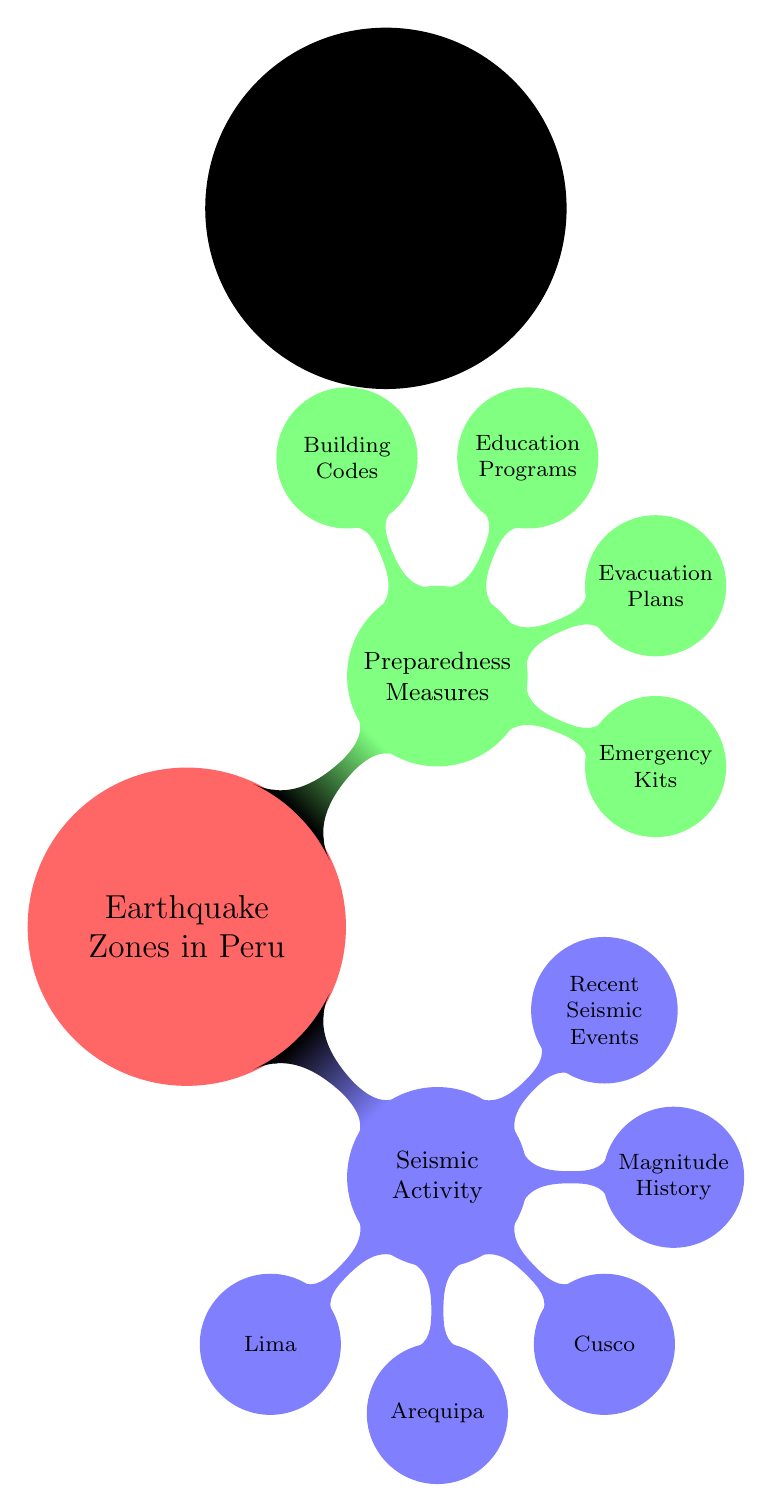What are the main categories shown in the diagram? The diagram has two main categories: "Seismic Activity" and "Preparedness Measures". These are the primary branches stemming from the central concept "Earthquake Zones in Peru".
Answer: Seismic Activity, Preparedness Measures How many locations are listed under "Seismic Activity"? Under "Seismic Activity," there are three locations mentioned: Lima, Arequipa, and Cusco. Thus, the total count is three.
Answer: 3 What specific precautionary measure is included under "Preparedness Measures"? The diagram lists several precautionary measures, including "Emergency Kits," which is one of the sub-nodes under "Preparedness Measures". This denotes an important aspect of earthquake preparedness.
Answer: Emergency Kits What is the relationship between "Magnitude History" and "Seismic Activity"? "Magnitude History" is a child node that falls under the parent node "Seismic Activity". This indicates that it is a subtopic that describes the historical earthquake magnitudes related to seismic activity.
Answer: Subtopic Which node has the greatest focus on education? The node "Education Programs" specifically emphasizes educational measures in relation to preparedness. It is clearly identified as a subtopic under "Preparedness Measures."
Answer: Education Programs What type of diagram is used to represent this information? The diagram uses a mind map format, which is indicated by the terminology used in the code and the structure of the visual representation that organizes concepts hierarchically.
Answer: Mind Map Which location under “Seismic Activity” is the first listed? The first listed location under “Seismic Activity” is "Lima". This is the first child node that branches from the "Seismic Activity" category.
Answer: Lima How many preparation measures are shown in the diagram? There are four preparation measures listed under "Preparedness Measures": Emergency Kits, Evacuation Plans, Education Programs, and Building Codes. Therefore, the count is four.
Answer: 4 